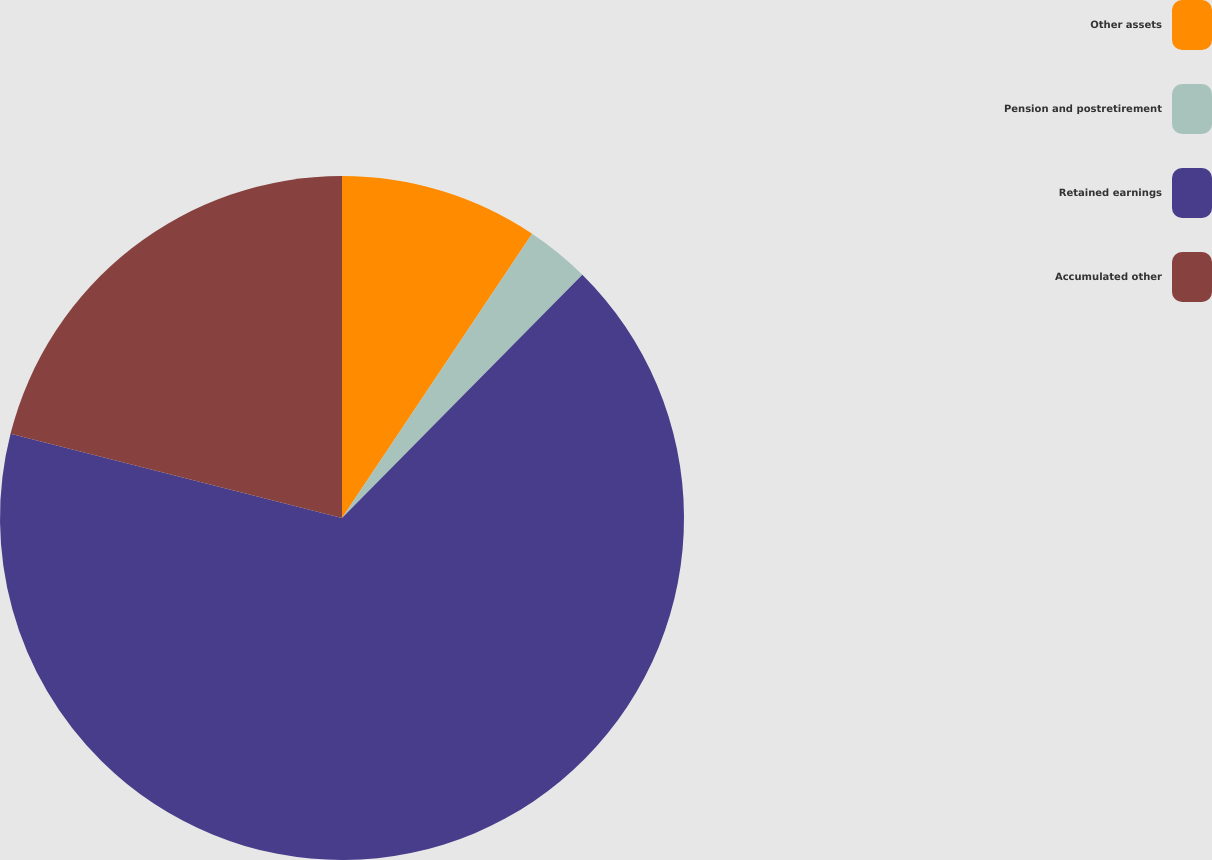<chart> <loc_0><loc_0><loc_500><loc_500><pie_chart><fcel>Other assets<fcel>Pension and postretirement<fcel>Retained earnings<fcel>Accumulated other<nl><fcel>9.38%<fcel>3.02%<fcel>66.55%<fcel>21.04%<nl></chart> 